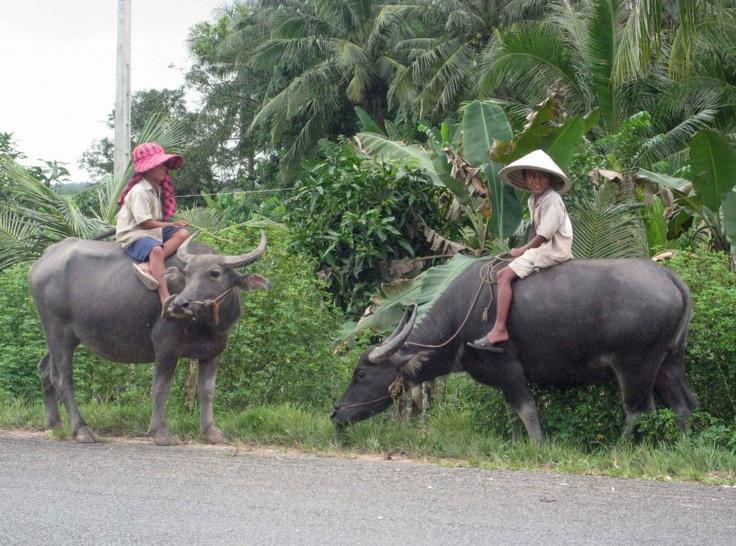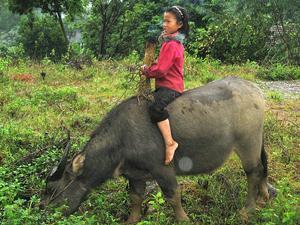The first image is the image on the left, the second image is the image on the right. Given the left and right images, does the statement "The left image contains two water buffaloes." hold true? Answer yes or no. Yes. The first image is the image on the left, the second image is the image on the right. Examine the images to the left and right. Is the description "One image shows only one person, who is wearing a cone-shaped hat and holding a stick, with at least one water buffalo standing in a wet area." accurate? Answer yes or no. No. 